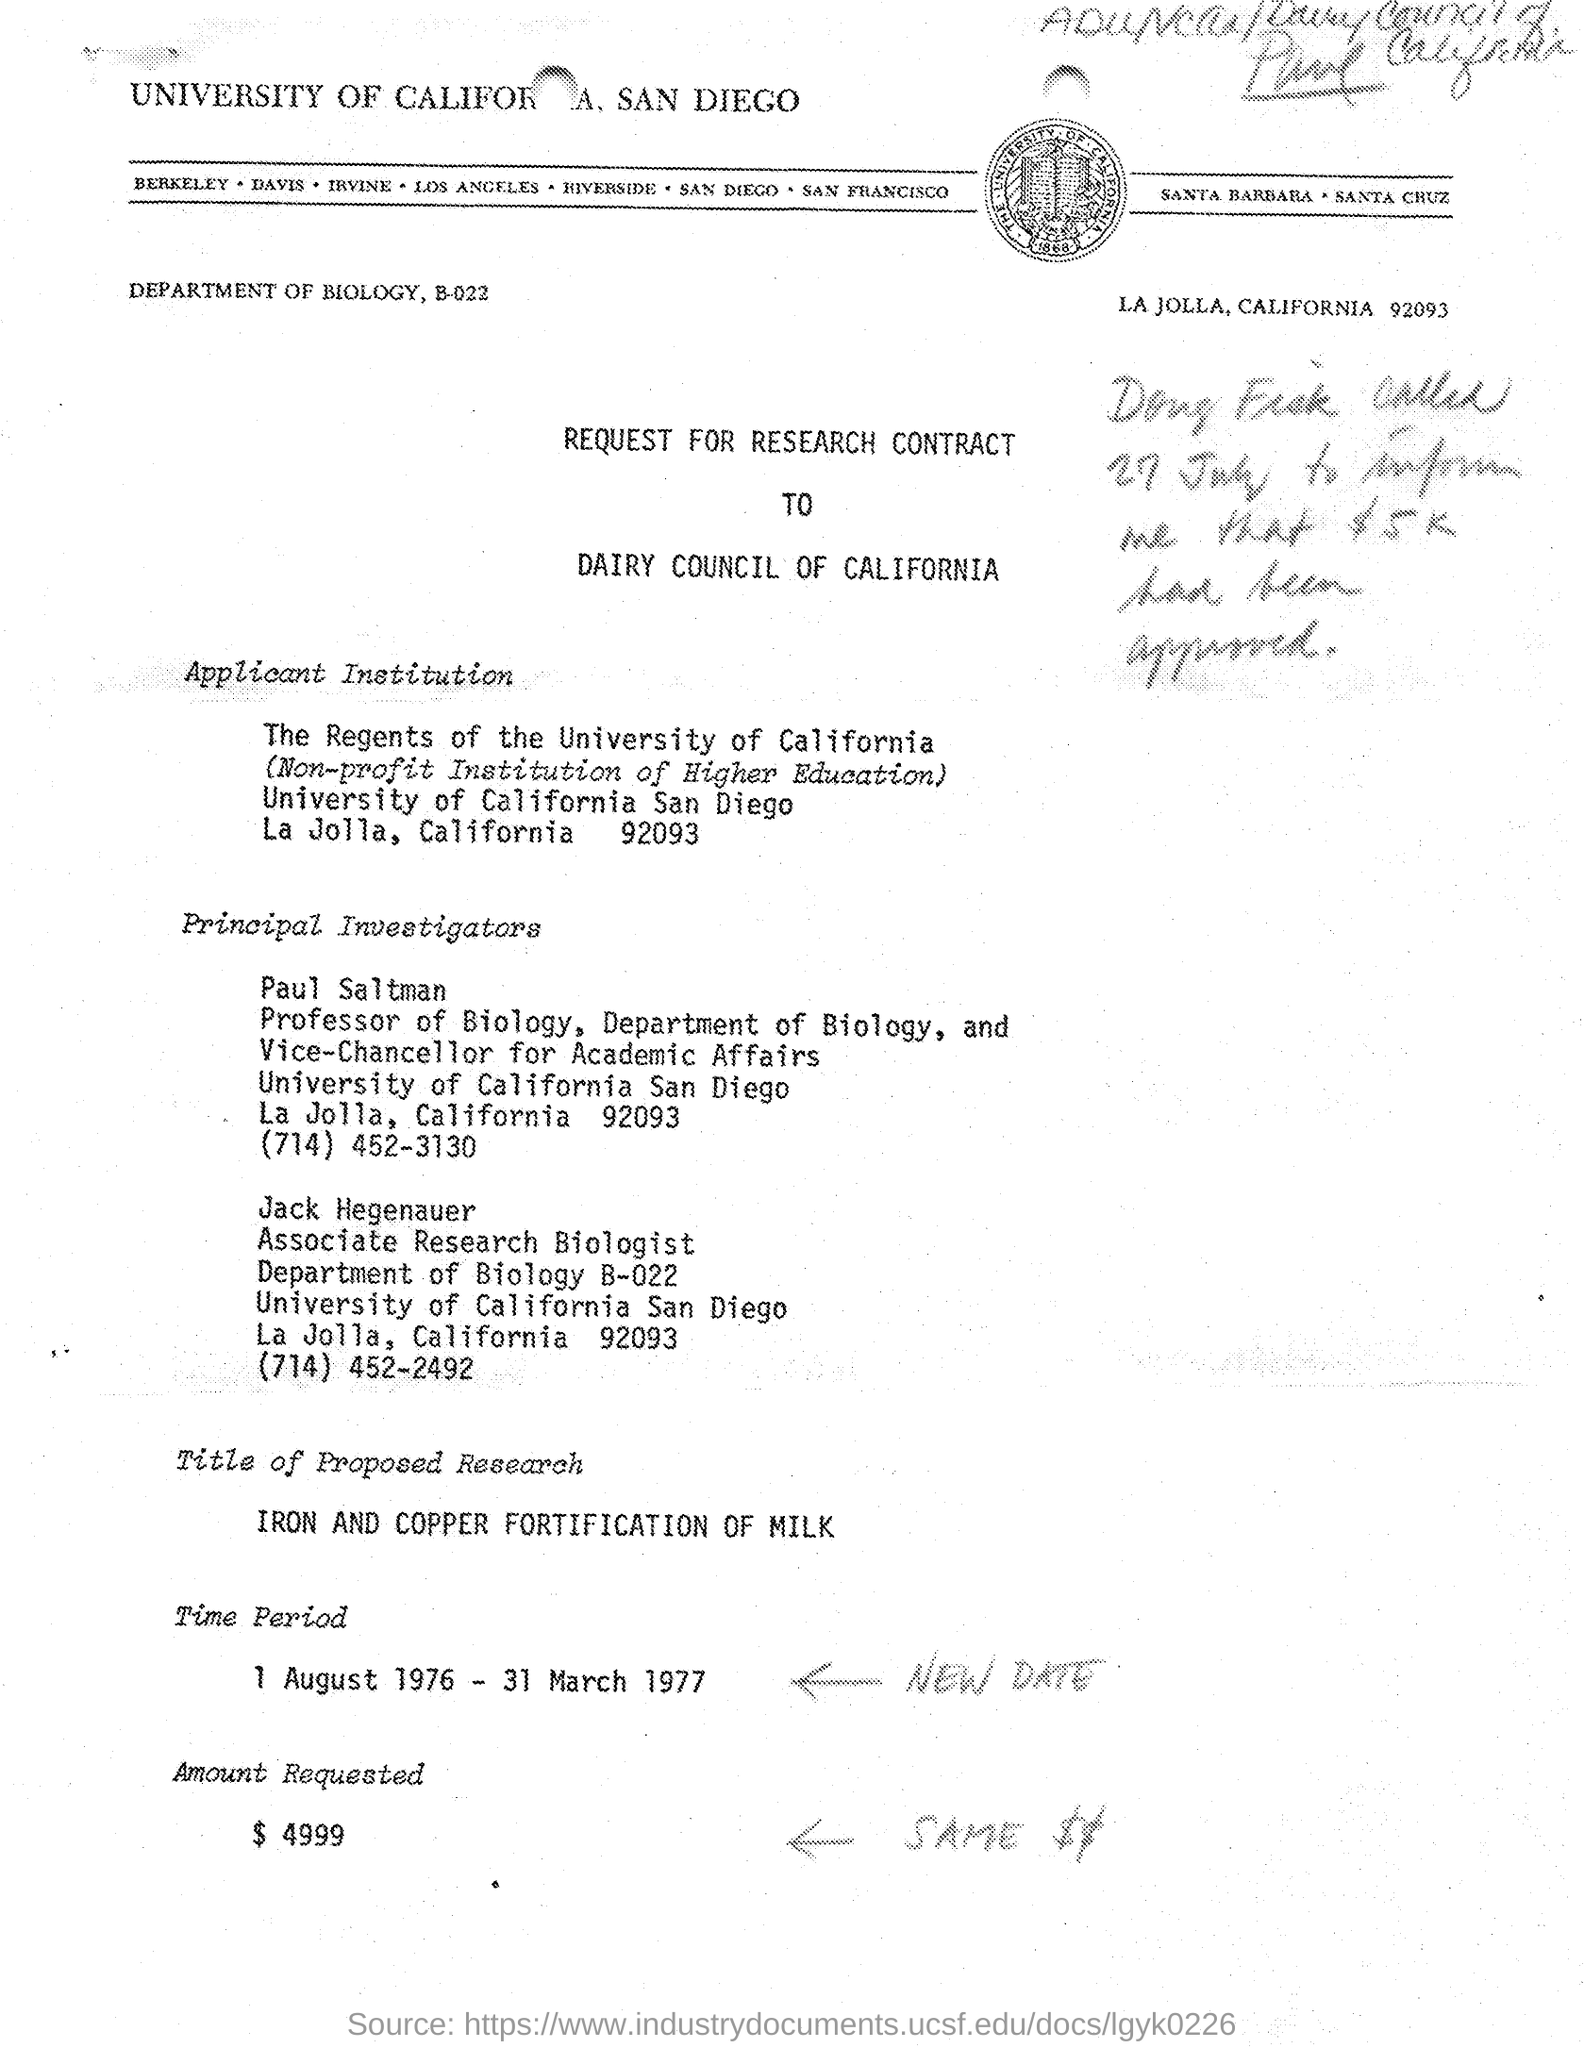Which university is mentioned in the header of the document?
Your answer should be very brief. UNIVERSITY OF CALIFORNIA, SAN DIEGO. What is the designation of Jack Hegenauer?
Provide a succinct answer. Associate Research Biologist. Who is the Vice-Chancellor for Academic Aaffairs, University of California, San Diego?
Your answer should be very brief. Paul Saltman. What is the Contact no of Paul Saltman mentioned in the document?
Your answer should be very brief. (714) 452-3130. What is the title of Proposed Research given in the document?
Provide a short and direct response. IRON AND COPPER FORTIFICATION OF MILK. What is the time-period mentioned in the document?
Your answer should be compact. 1 August 1976 - 31 March 1977. What is the Amount Requested as per the document?
Keep it short and to the point. 4999. 